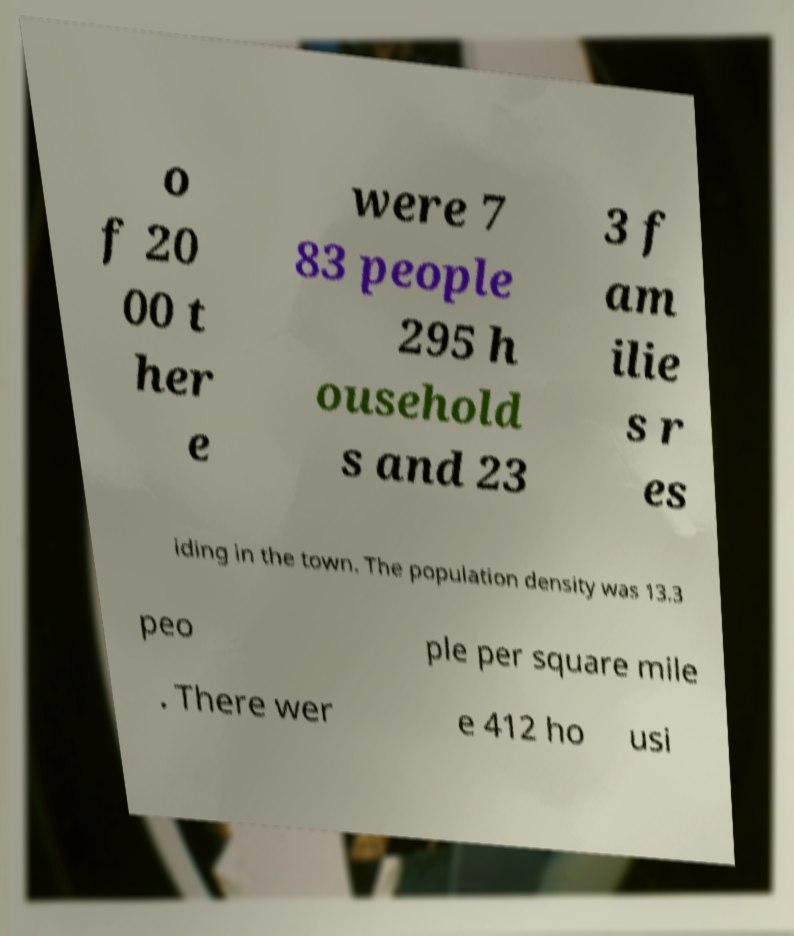Can you accurately transcribe the text from the provided image for me? o f 20 00 t her e were 7 83 people 295 h ousehold s and 23 3 f am ilie s r es iding in the town. The population density was 13.3 peo ple per square mile . There wer e 412 ho usi 